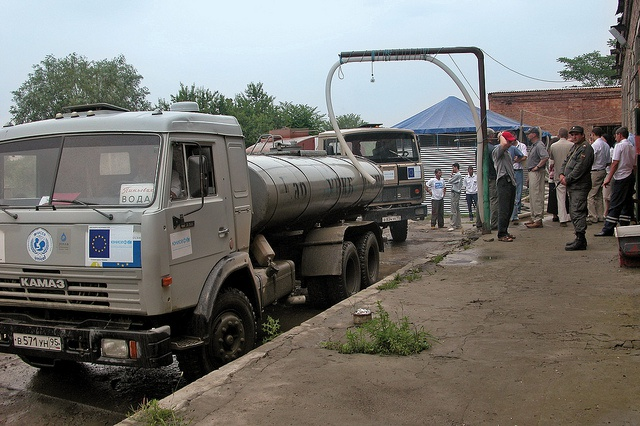Describe the objects in this image and their specific colors. I can see truck in lightblue, black, gray, darkgray, and lightgray tones, truck in lightblue, black, gray, and darkgray tones, people in lightblue, black, gray, and maroon tones, people in lightblue, black, gray, darkgray, and maroon tones, and people in lightblue, black, gray, maroon, and darkgray tones in this image. 